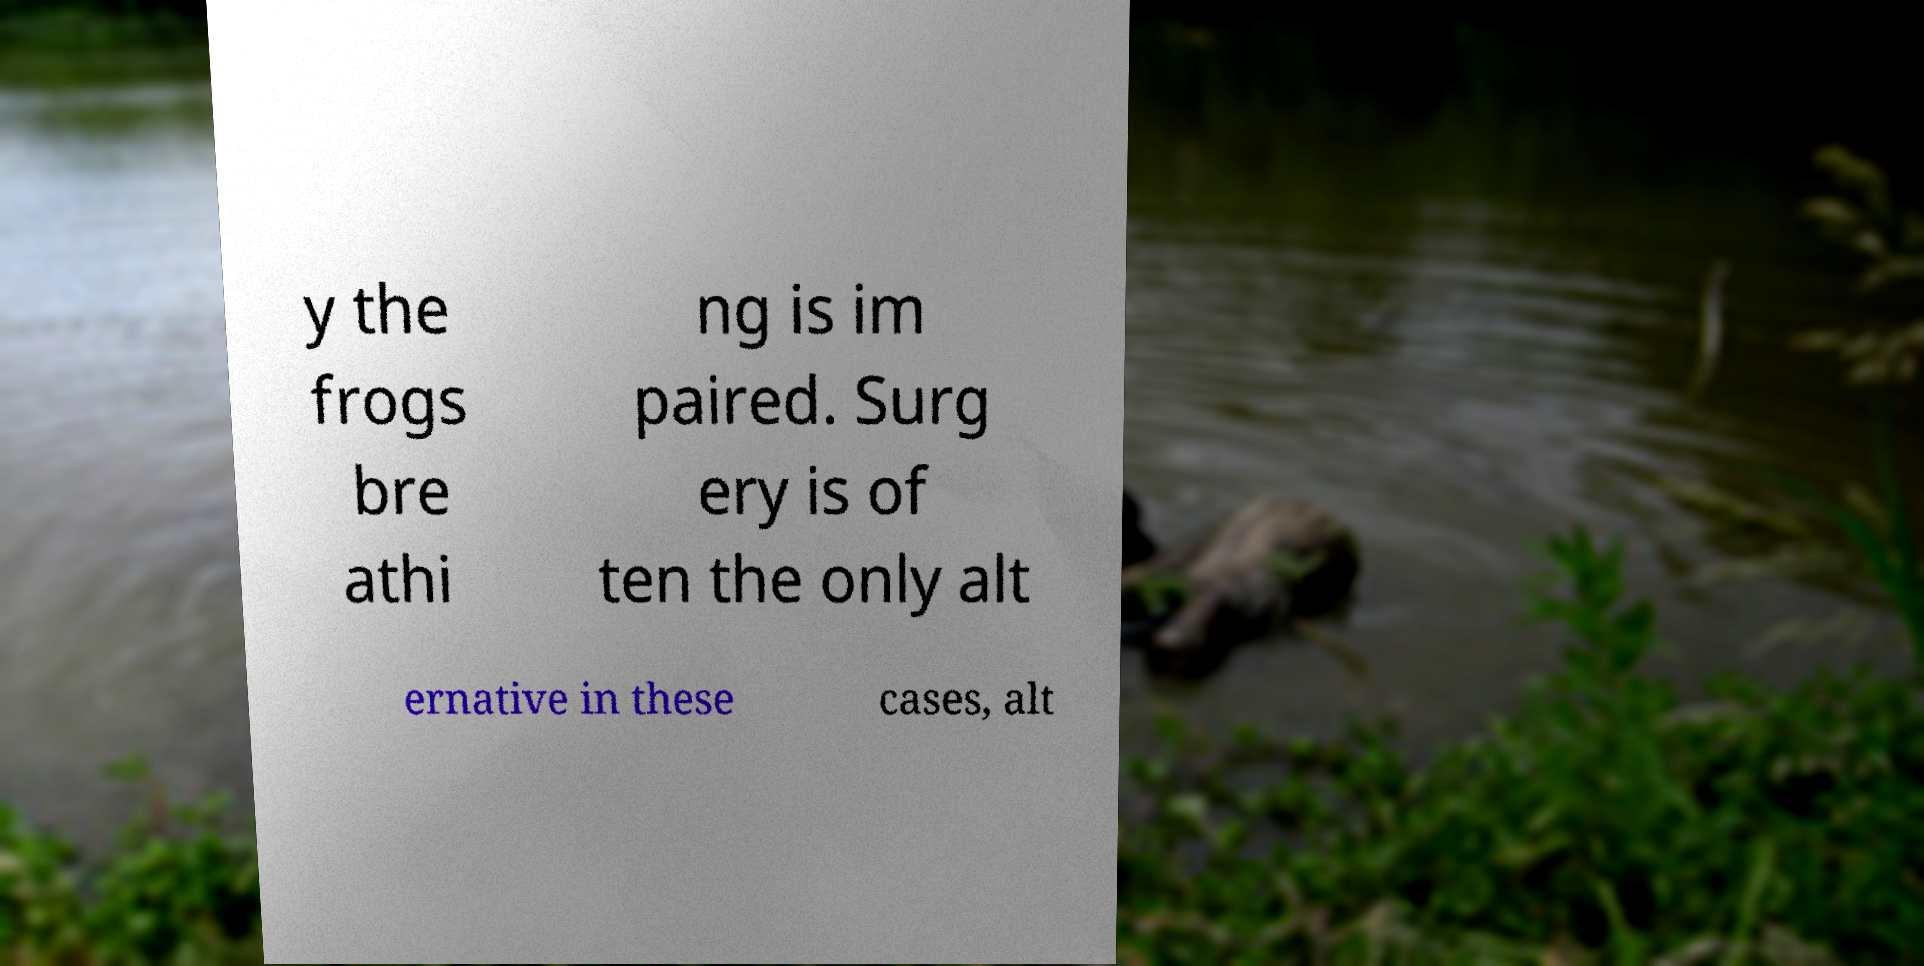I need the written content from this picture converted into text. Can you do that? y the frogs bre athi ng is im paired. Surg ery is of ten the only alt ernative in these cases, alt 